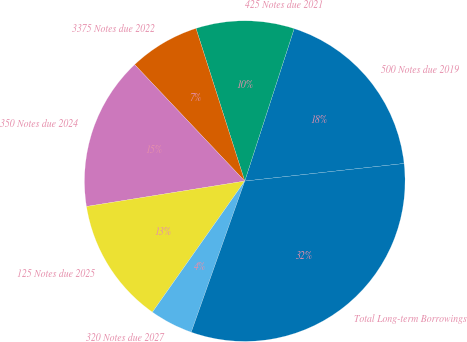Convert chart. <chart><loc_0><loc_0><loc_500><loc_500><pie_chart><fcel>500 Notes due 2019<fcel>425 Notes due 2021<fcel>3375 Notes due 2022<fcel>350 Notes due 2024<fcel>125 Notes due 2025<fcel>320 Notes due 2027<fcel>Total Long-term Borrowings<nl><fcel>18.26%<fcel>9.91%<fcel>7.13%<fcel>15.48%<fcel>12.7%<fcel>4.35%<fcel>32.17%<nl></chart> 